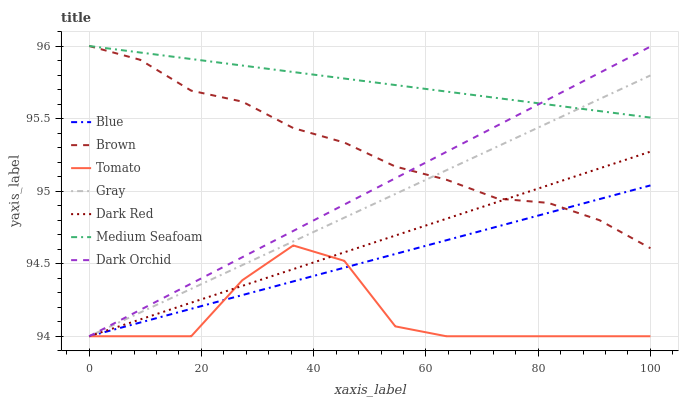Does Tomato have the minimum area under the curve?
Answer yes or no. Yes. Does Medium Seafoam have the maximum area under the curve?
Answer yes or no. Yes. Does Brown have the minimum area under the curve?
Answer yes or no. No. Does Brown have the maximum area under the curve?
Answer yes or no. No. Is Medium Seafoam the smoothest?
Answer yes or no. Yes. Is Tomato the roughest?
Answer yes or no. Yes. Is Brown the smoothest?
Answer yes or no. No. Is Brown the roughest?
Answer yes or no. No. Does Blue have the lowest value?
Answer yes or no. Yes. Does Brown have the lowest value?
Answer yes or no. No. Does Medium Seafoam have the highest value?
Answer yes or no. Yes. Does Gray have the highest value?
Answer yes or no. No. Is Tomato less than Brown?
Answer yes or no. Yes. Is Medium Seafoam greater than Blue?
Answer yes or no. Yes. Does Dark Orchid intersect Tomato?
Answer yes or no. Yes. Is Dark Orchid less than Tomato?
Answer yes or no. No. Is Dark Orchid greater than Tomato?
Answer yes or no. No. Does Tomato intersect Brown?
Answer yes or no. No. 